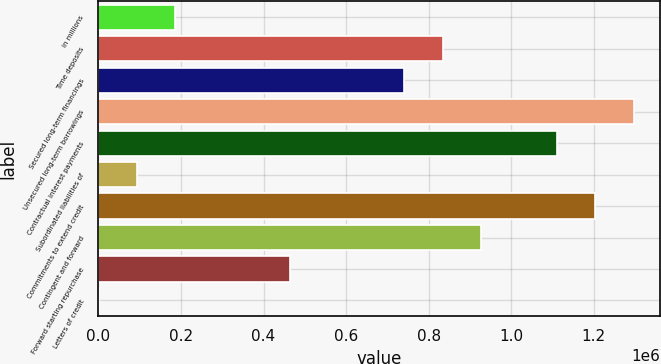<chart> <loc_0><loc_0><loc_500><loc_500><bar_chart><fcel>in millions<fcel>Time deposits<fcel>Secured long-term financings<fcel>Unsecured long-term borrowings<fcel>Contractual interest payments<fcel>Subordinated liabilities of<fcel>Commitments to extend credit<fcel>Contingent and forward<fcel>Forward starting repurchase<fcel>Letters of credit<nl><fcel>185488<fcel>833824<fcel>741204<fcel>1.29692e+06<fcel>1.11168e+06<fcel>92868.4<fcel>1.2043e+06<fcel>926443<fcel>463346<fcel>249<nl></chart> 